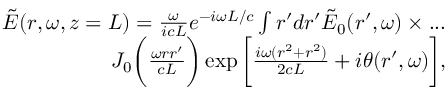<formula> <loc_0><loc_0><loc_500><loc_500>\begin{array} { r } { \tilde { E } ( r , \omega , z = L ) = \frac { \omega } { i c L } e ^ { - i \omega L / c } \int r ^ { \prime } d r ^ { \prime } \tilde { E } _ { 0 } ( r ^ { \prime } , \omega ) \times \dots } \\ { J _ { 0 } \left ( \frac { \omega r r ^ { \prime } } { c L } \right ) \exp { \left [ \frac { i \omega ( r ^ { 2 } + r ^ { 2 } ) } { 2 c L } + i \theta ( r ^ { \prime } , \omega ) \right ] } , } \end{array}</formula> 